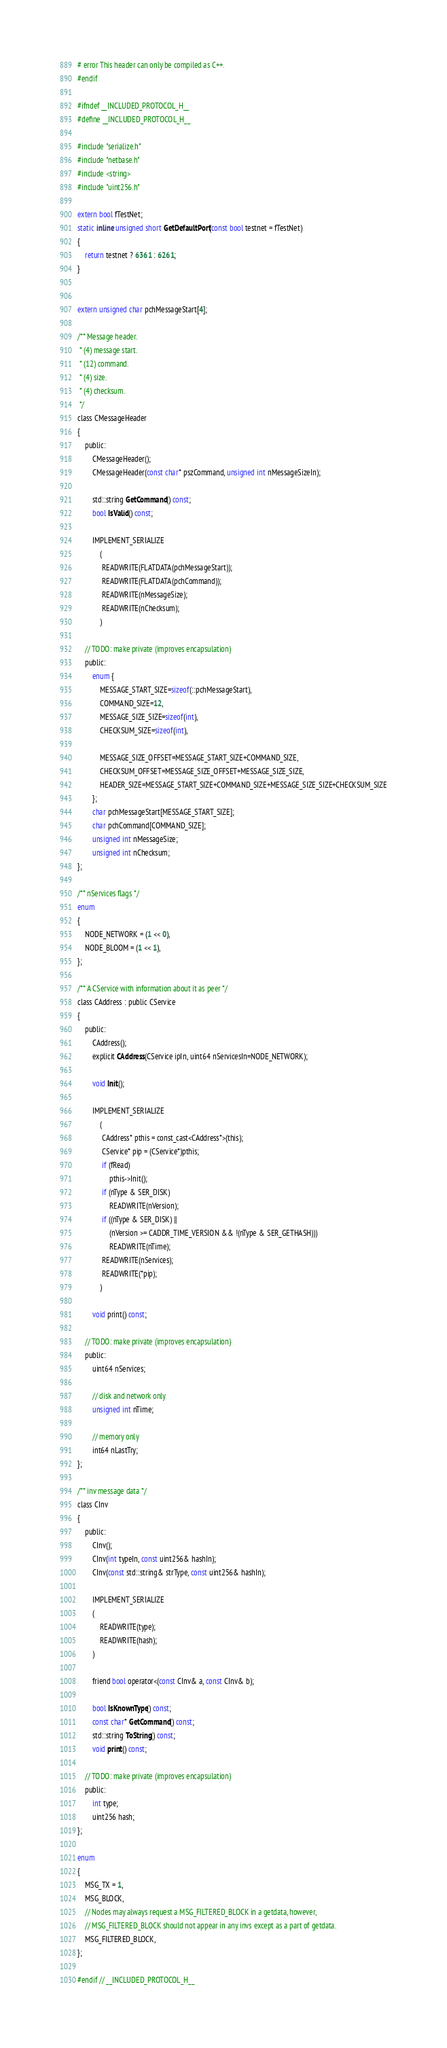<code> <loc_0><loc_0><loc_500><loc_500><_C_># error This header can only be compiled as C++.
#endif

#ifndef __INCLUDED_PROTOCOL_H__
#define __INCLUDED_PROTOCOL_H__

#include "serialize.h"
#include "netbase.h"
#include <string>
#include "uint256.h"

extern bool fTestNet;
static inline unsigned short GetDefaultPort(const bool testnet = fTestNet)
{
    return testnet ? 6361 : 6261;
}


extern unsigned char pchMessageStart[4];

/** Message header.
 * (4) message start.
 * (12) command.
 * (4) size.
 * (4) checksum.
 */
class CMessageHeader
{
    public:
        CMessageHeader();
        CMessageHeader(const char* pszCommand, unsigned int nMessageSizeIn);

        std::string GetCommand() const;
        bool IsValid() const;

        IMPLEMENT_SERIALIZE
            (
             READWRITE(FLATDATA(pchMessageStart));
             READWRITE(FLATDATA(pchCommand));
             READWRITE(nMessageSize);
             READWRITE(nChecksum);
            )

    // TODO: make private (improves encapsulation)
    public:
        enum {
            MESSAGE_START_SIZE=sizeof(::pchMessageStart),
            COMMAND_SIZE=12,
            MESSAGE_SIZE_SIZE=sizeof(int),
            CHECKSUM_SIZE=sizeof(int),

            MESSAGE_SIZE_OFFSET=MESSAGE_START_SIZE+COMMAND_SIZE,
            CHECKSUM_OFFSET=MESSAGE_SIZE_OFFSET+MESSAGE_SIZE_SIZE,
            HEADER_SIZE=MESSAGE_START_SIZE+COMMAND_SIZE+MESSAGE_SIZE_SIZE+CHECKSUM_SIZE
        };
        char pchMessageStart[MESSAGE_START_SIZE];
        char pchCommand[COMMAND_SIZE];
        unsigned int nMessageSize;
        unsigned int nChecksum;
};

/** nServices flags */
enum
{
    NODE_NETWORK = (1 << 0),
    NODE_BLOOM = (1 << 1),
};

/** A CService with information about it as peer */
class CAddress : public CService
{
    public:
        CAddress();
        explicit CAddress(CService ipIn, uint64 nServicesIn=NODE_NETWORK);

        void Init();

        IMPLEMENT_SERIALIZE
            (
             CAddress* pthis = const_cast<CAddress*>(this);
             CService* pip = (CService*)pthis;
             if (fRead)
                 pthis->Init();
             if (nType & SER_DISK)
                 READWRITE(nVersion);
             if ((nType & SER_DISK) ||
                 (nVersion >= CADDR_TIME_VERSION && !(nType & SER_GETHASH)))
                 READWRITE(nTime);
             READWRITE(nServices);
             READWRITE(*pip);
            )

        void print() const;

    // TODO: make private (improves encapsulation)
    public:
        uint64 nServices;

        // disk and network only
        unsigned int nTime;

        // memory only
        int64 nLastTry;
};

/** inv message data */
class CInv
{
    public:
        CInv();
        CInv(int typeIn, const uint256& hashIn);
        CInv(const std::string& strType, const uint256& hashIn);

        IMPLEMENT_SERIALIZE
        (
            READWRITE(type);
            READWRITE(hash);
        )

        friend bool operator<(const CInv& a, const CInv& b);

        bool IsKnownType() const;
        const char* GetCommand() const;
        std::string ToString() const;
        void print() const;

    // TODO: make private (improves encapsulation)
    public:
        int type;
        uint256 hash;
};

enum
{
    MSG_TX = 1,
    MSG_BLOCK,
    // Nodes may always request a MSG_FILTERED_BLOCK in a getdata, however,
    // MSG_FILTERED_BLOCK should not appear in any invs except as a part of getdata.
    MSG_FILTERED_BLOCK,
};

#endif // __INCLUDED_PROTOCOL_H__
</code> 